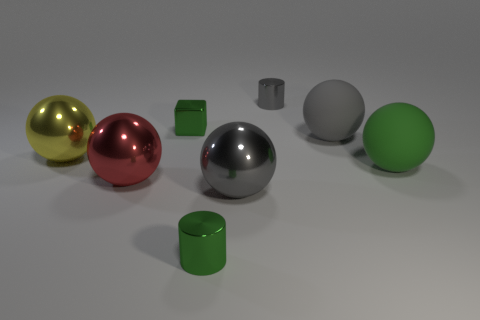There is a tiny cylinder that is the same color as the block; what material is it?
Provide a succinct answer. Metal. How many rubber balls are the same color as the metallic block?
Make the answer very short. 1. Is there a small green thing of the same shape as the small gray metal object?
Provide a succinct answer. Yes. Is the material of the big green object the same as the gray ball behind the gray metallic ball?
Offer a terse response. Yes. Is there a big thing that has the same color as the block?
Keep it short and to the point. Yes. How many other objects are there of the same material as the big yellow sphere?
Your answer should be compact. 5. There is a tiny cube; is its color the same as the tiny thing in front of the tiny green block?
Ensure brevity in your answer.  Yes. Is the number of green shiny cylinders right of the yellow shiny sphere greater than the number of big purple metallic cylinders?
Keep it short and to the point. Yes. There is a metal cylinder that is in front of the large yellow metal sphere that is in front of the gray matte object; what number of big red balls are behind it?
Ensure brevity in your answer.  1. There is a rubber object that is to the right of the big gray rubber sphere; is its shape the same as the big red shiny object?
Give a very brief answer. Yes. 